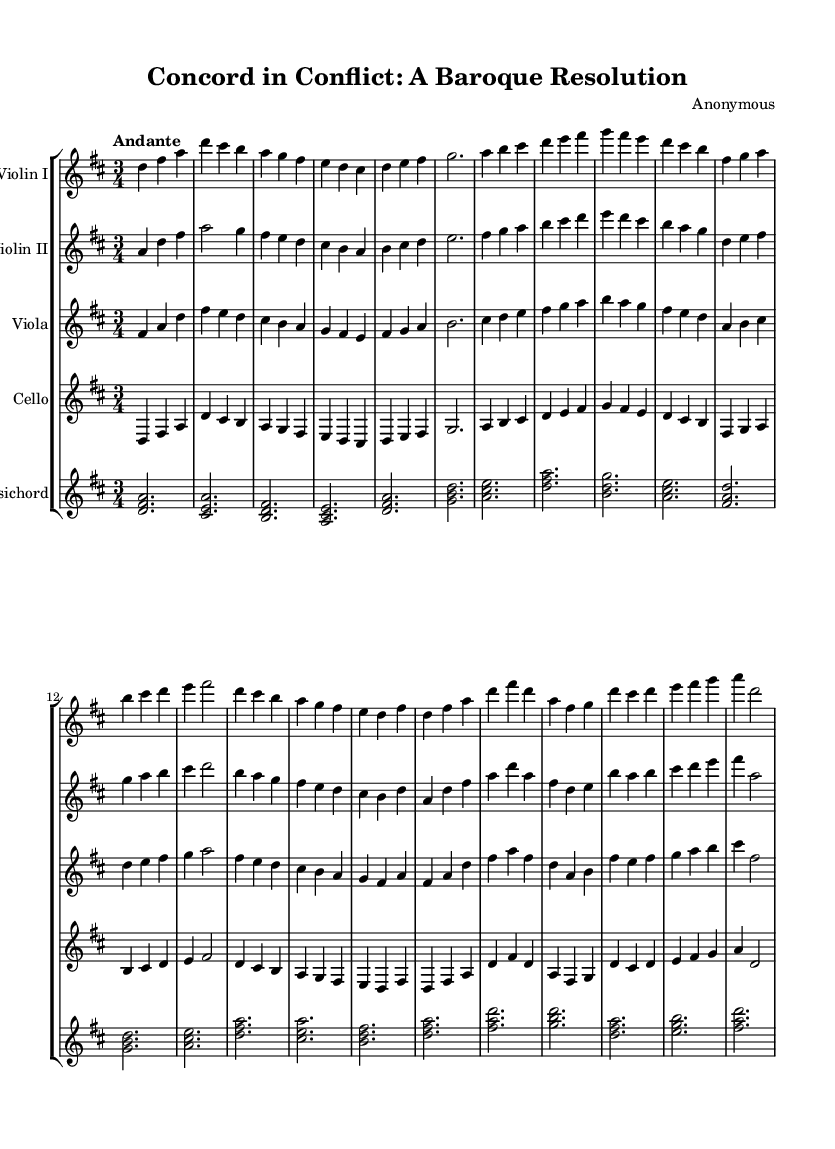What is the key signature of this music? The key signature is D major, which has two sharps: F sharp and C sharp. This can be determined by identifying the key signature notation at the beginning of the music before the first measure.
Answer: D major What is the time signature of the piece? The time signature of the piece is 3/4, indicated at the beginning of the sheet music. This means there are three beats in each measure and the quarter note gets one beat.
Answer: 3/4 What tempo marking is indicated in the music? The tempo marking indicated in the music is "Andante," which generally signifies a moderate tempo, typically around 76 to 108 beats per minute. This is found at the start, showing how fast the piece should be played.
Answer: Andante How many sections can be identified in this orchestral suite? The orchestral suite is structured into three distinct sections: "The Discord," "The Mediation," and "The Resolution," each depicting a different stage of conflict resolution. This can be inferred from the headings marked within the music.
Answer: Three Which instruments are included in the orchestration? The orchestration includes Violin I, Violin II, Viola, Cello, and Harpsichord. Each part is indicated on a separate staff, clearly showing the different instrumental lines throughout the piece.
Answer: Violin I, Violin II, Viola, Cello, Harpsichord What musical form does this piece exhibit? The piece exhibits a ternary form, which is characterized by the A-B-A structure where the first and third sections share thematic material, while the middle section contrasts. This can be deduced from the outlined themes in the music indicating a return to earlier material.
Answer: Ternary form Which theme represents the climax of the conflict? The climax of the conflict is represented in the section labeled "The Discord - Development," showcasing heightened tension through the energetic musical phrases implying conflict resolution. This section is notable for its dynamic development in the themes.
Answer: The Discord - Development 